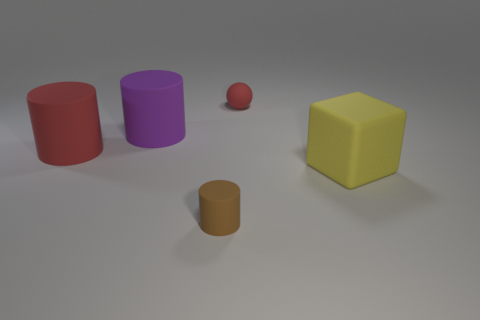What number of large matte things are behind the large purple thing that is behind the large rubber object that is to the right of the small red thing?
Your answer should be compact. 0. The tiny thing that is the same material as the small red ball is what color?
Your response must be concise. Brown. There is a matte cylinder in front of the yellow thing; is it the same size as the big rubber cube?
Ensure brevity in your answer.  No. What number of things are either red objects or big yellow matte cubes?
Offer a terse response. 3. Is there a shiny cylinder of the same size as the red rubber cylinder?
Your answer should be very brief. No. There is a large cylinder in front of the purple matte object; is its color the same as the ball?
Offer a terse response. Yes. How many brown things are either large rubber cubes or cylinders?
Ensure brevity in your answer.  1. What number of cylinders are the same color as the sphere?
Your answer should be very brief. 1. Do the purple cylinder and the brown thing have the same material?
Give a very brief answer. Yes. What number of brown matte objects are behind the tiny thing behind the big rubber cube?
Keep it short and to the point. 0. 